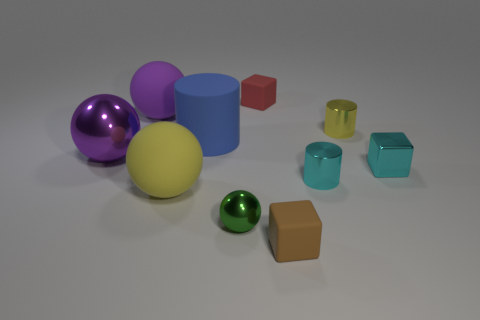Subtract all brown blocks. How many purple balls are left? 2 Subtract all rubber blocks. How many blocks are left? 1 Subtract all yellow spheres. How many spheres are left? 3 Subtract 1 cylinders. How many cylinders are left? 2 Subtract all cubes. How many objects are left? 7 Subtract all small red matte blocks. Subtract all green balls. How many objects are left? 8 Add 4 yellow metallic cylinders. How many yellow metallic cylinders are left? 5 Add 7 large blue cylinders. How many large blue cylinders exist? 8 Subtract 0 red balls. How many objects are left? 10 Subtract all brown balls. Subtract all cyan cylinders. How many balls are left? 4 